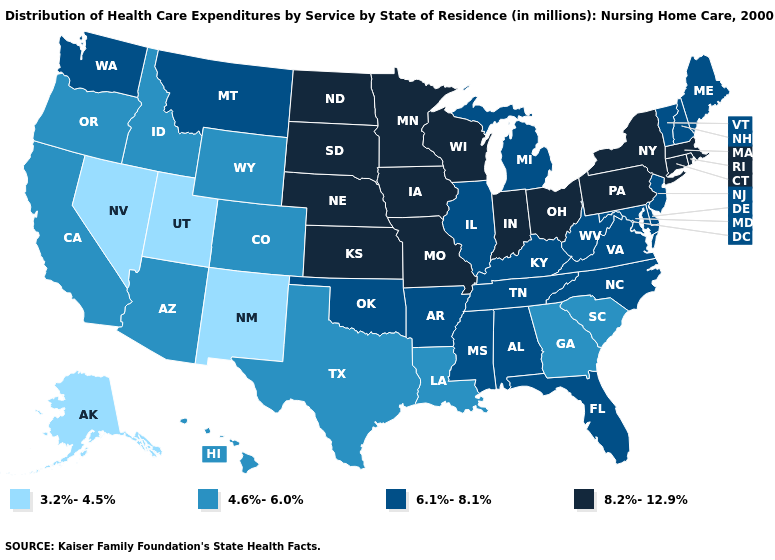Is the legend a continuous bar?
Write a very short answer. No. Does New Mexico have the lowest value in the USA?
Be succinct. Yes. Does the map have missing data?
Concise answer only. No. What is the highest value in the MidWest ?
Answer briefly. 8.2%-12.9%. Does the map have missing data?
Be succinct. No. Name the states that have a value in the range 4.6%-6.0%?
Answer briefly. Arizona, California, Colorado, Georgia, Hawaii, Idaho, Louisiana, Oregon, South Carolina, Texas, Wyoming. Does Alaska have the highest value in the USA?
Quick response, please. No. Name the states that have a value in the range 3.2%-4.5%?
Write a very short answer. Alaska, Nevada, New Mexico, Utah. Which states have the lowest value in the West?
Be succinct. Alaska, Nevada, New Mexico, Utah. Does Rhode Island have the highest value in the USA?
Give a very brief answer. Yes. What is the value of Louisiana?
Give a very brief answer. 4.6%-6.0%. Is the legend a continuous bar?
Be succinct. No. Does Washington have a higher value than Illinois?
Answer briefly. No. Does the first symbol in the legend represent the smallest category?
Concise answer only. Yes. Name the states that have a value in the range 6.1%-8.1%?
Write a very short answer. Alabama, Arkansas, Delaware, Florida, Illinois, Kentucky, Maine, Maryland, Michigan, Mississippi, Montana, New Hampshire, New Jersey, North Carolina, Oklahoma, Tennessee, Vermont, Virginia, Washington, West Virginia. 